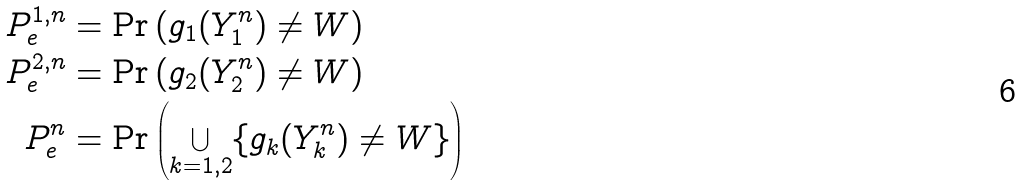Convert formula to latex. <formula><loc_0><loc_0><loc_500><loc_500>P _ { e } ^ { 1 , n } & = \Pr \left ( g _ { 1 } ( Y _ { 1 } ^ { n } ) \neq W \right ) \\ P _ { e } ^ { 2 , n } & = \Pr \left ( g _ { 2 } ( Y _ { 2 } ^ { n } ) \neq W \right ) \\ P _ { e } ^ { n } & = \Pr \left ( \bigcup _ { k = 1 , 2 } \{ g _ { k } ( Y _ { k } ^ { n } ) \neq W \} \right )</formula> 